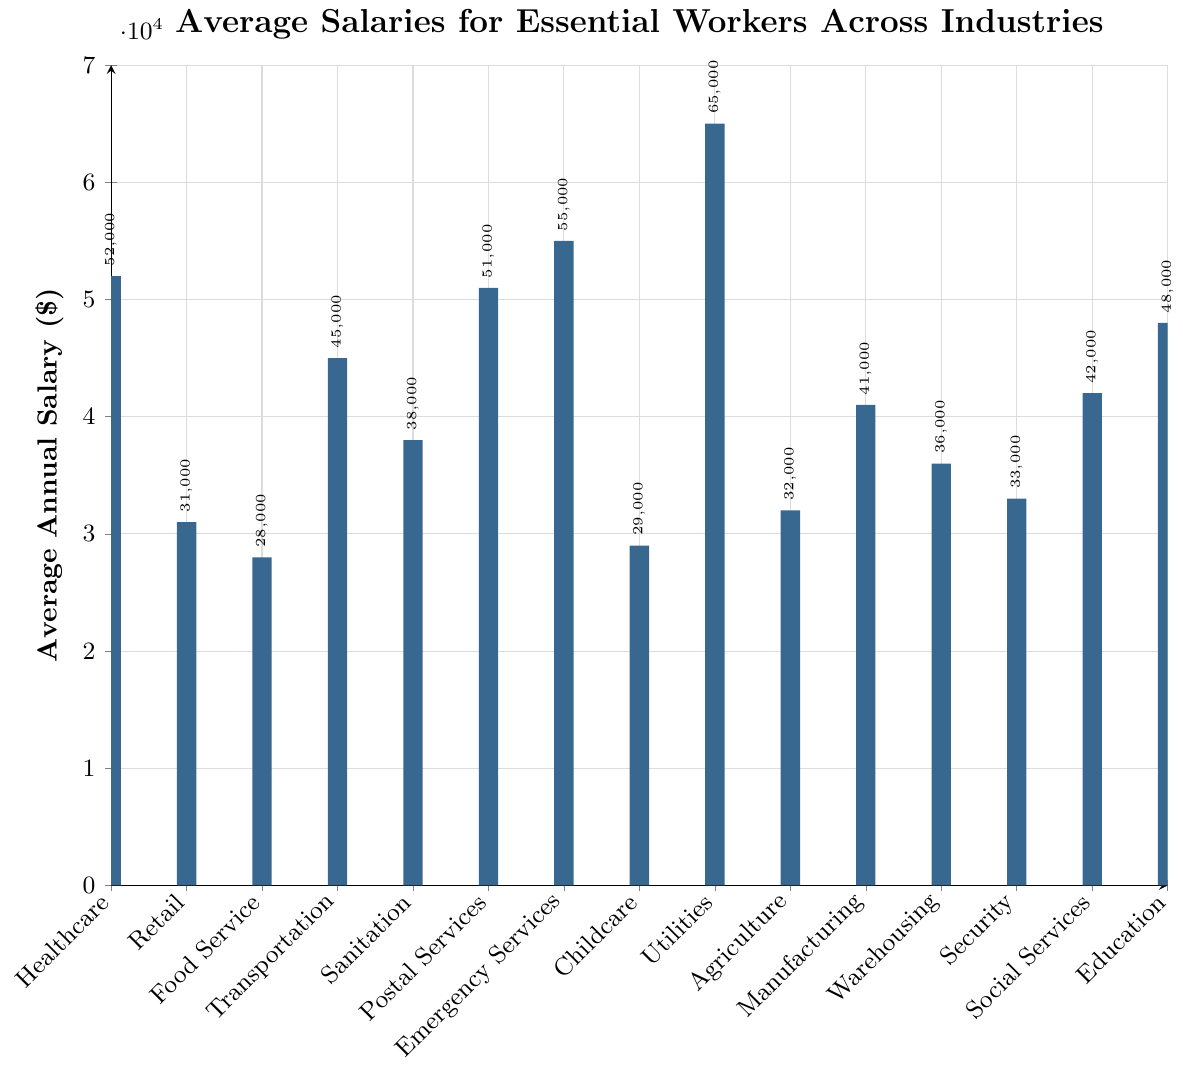Which industry has the highest average salary? To find this, locate the tallest bar on the bar chart. The Utilities industry has the highest average salary with $65,000.
Answer: Utilities Which industry has the lowest average salary? To determine the lowest, identify the shortest bar in the figure. The Food Service industry has the lowest average salary, with $28,000.
Answer: Food Service What is the average annual salary difference between Emergency Services and Postal Services? Find the bars representing Emergency Services and Postal Services. Calculate the difference between their salaries: $55,000 (Emergency Services) - $51,000 (Postal Services) = $4,000.
Answer: $4,000 Which industries have an average annual salary greater than $50,000? Identify the bars where the value exceeds $50,000. These industries are Healthcare ($52,000), Postal Services ($51,000), Emergency Services ($55,000), and Utilities ($65,000).
Answer: Healthcare, Postal Services, Emergency Services, Utilities What is the combined average salary for Retail, Food Service, and Childcare industries? Sum the average salaries for these industries: $31,000 (Retail) + $28,000 (Food Service) + $29,000 (Childcare) = $88,000.
Answer: $88,000 How much more do workers in Healthcare earn on average compared to those in Agriculture? Find the salary for Healthcare and Agriculture and calculate the difference: $52,000 (Healthcare) - $32,000 (Agriculture) = $20,000.
Answer: $20,000 What is the ratio of the average salary of Social Services to that of Security? Divide the average salary of Social Services by that of Security: $42,000 (Social Services) / $33,000 (Security) = 1.27.
Answer: 1.27 Which industry is closest to the $40,000 average annual salary mark? Identify the bar that is nearest to $40,000. Manufacturing, with an average salary of $41,000, is closest to this mark.
Answer: Manufacturing Compare the average salaries of Healthcare and Education. Which industry has a higher average salary and by how much? Identify the bars for Healthcare ($52,000) and Education ($48,000). Healthcare has a higher average salary with a difference of $52,000 - $48,000 = $4,000.
Answer: Healthcare, $4,000 